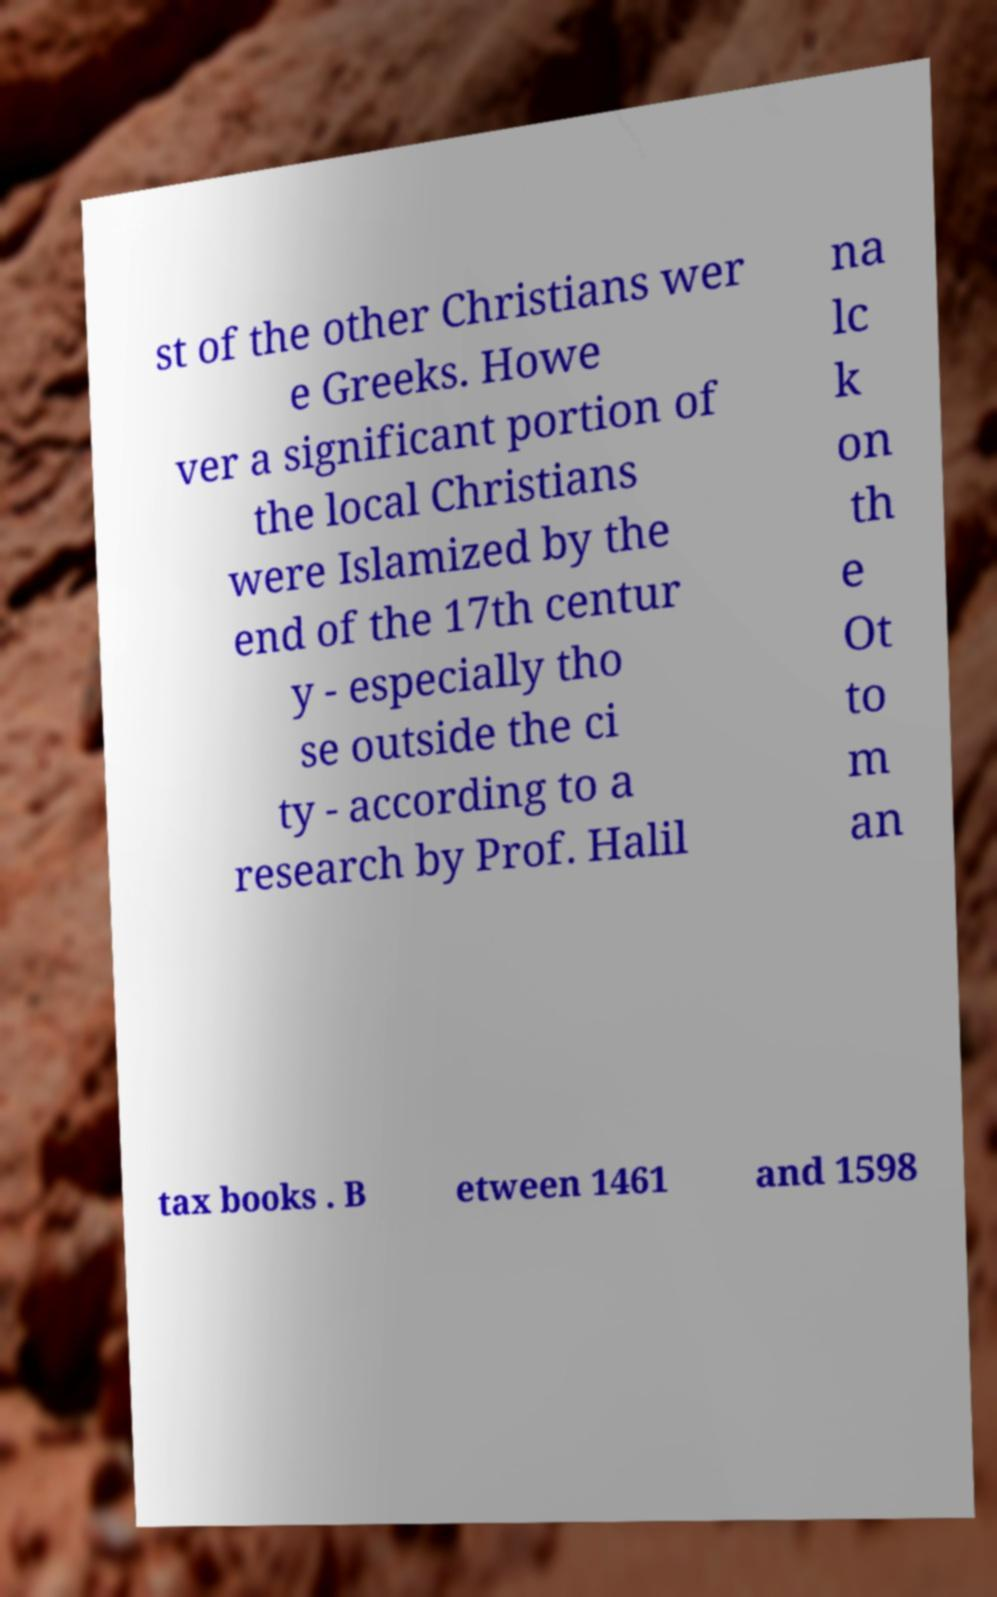I need the written content from this picture converted into text. Can you do that? st of the other Christians wer e Greeks. Howe ver a significant portion of the local Christians were Islamized by the end of the 17th centur y - especially tho se outside the ci ty - according to a research by Prof. Halil na lc k on th e Ot to m an tax books . B etween 1461 and 1598 